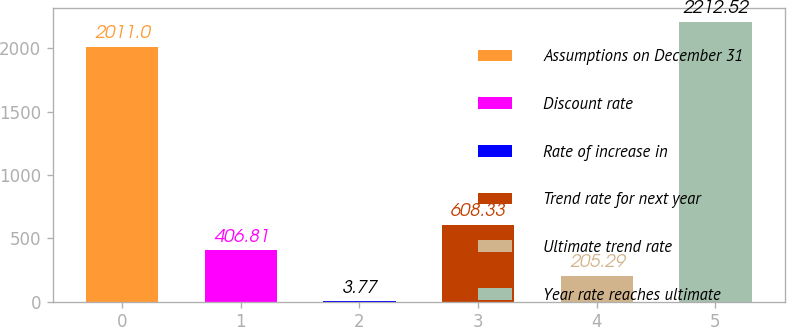Convert chart to OTSL. <chart><loc_0><loc_0><loc_500><loc_500><bar_chart><fcel>Assumptions on December 31<fcel>Discount rate<fcel>Rate of increase in<fcel>Trend rate for next year<fcel>Ultimate trend rate<fcel>Year rate reaches ultimate<nl><fcel>2011<fcel>406.81<fcel>3.77<fcel>608.33<fcel>205.29<fcel>2212.52<nl></chart> 